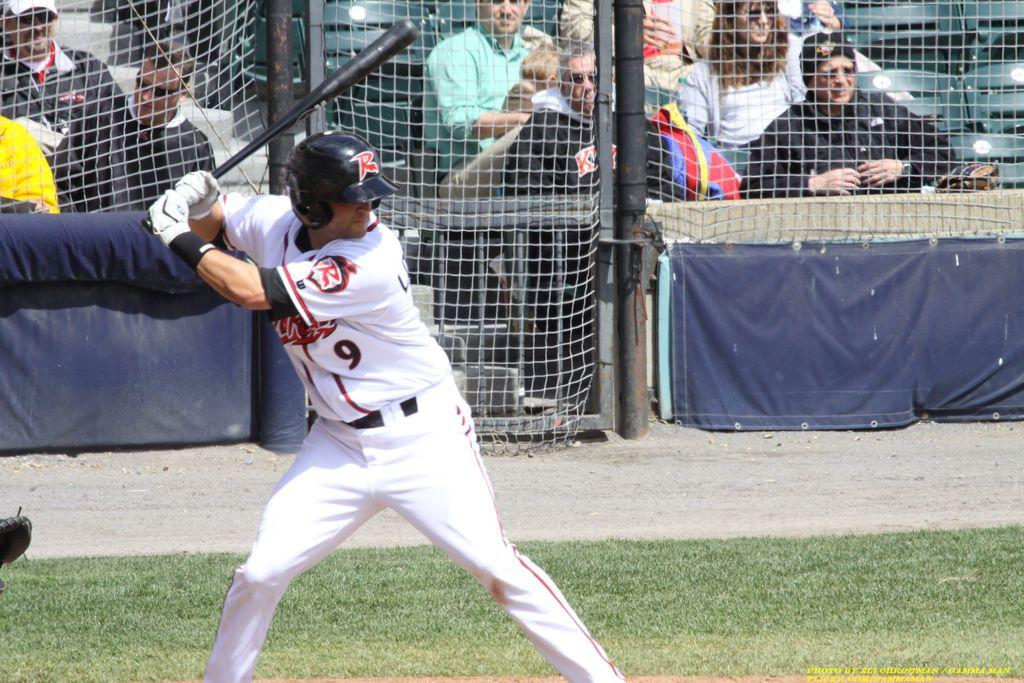<image>
Offer a succinct explanation of the picture presented. Player number 9 gets ready to swing his bat 